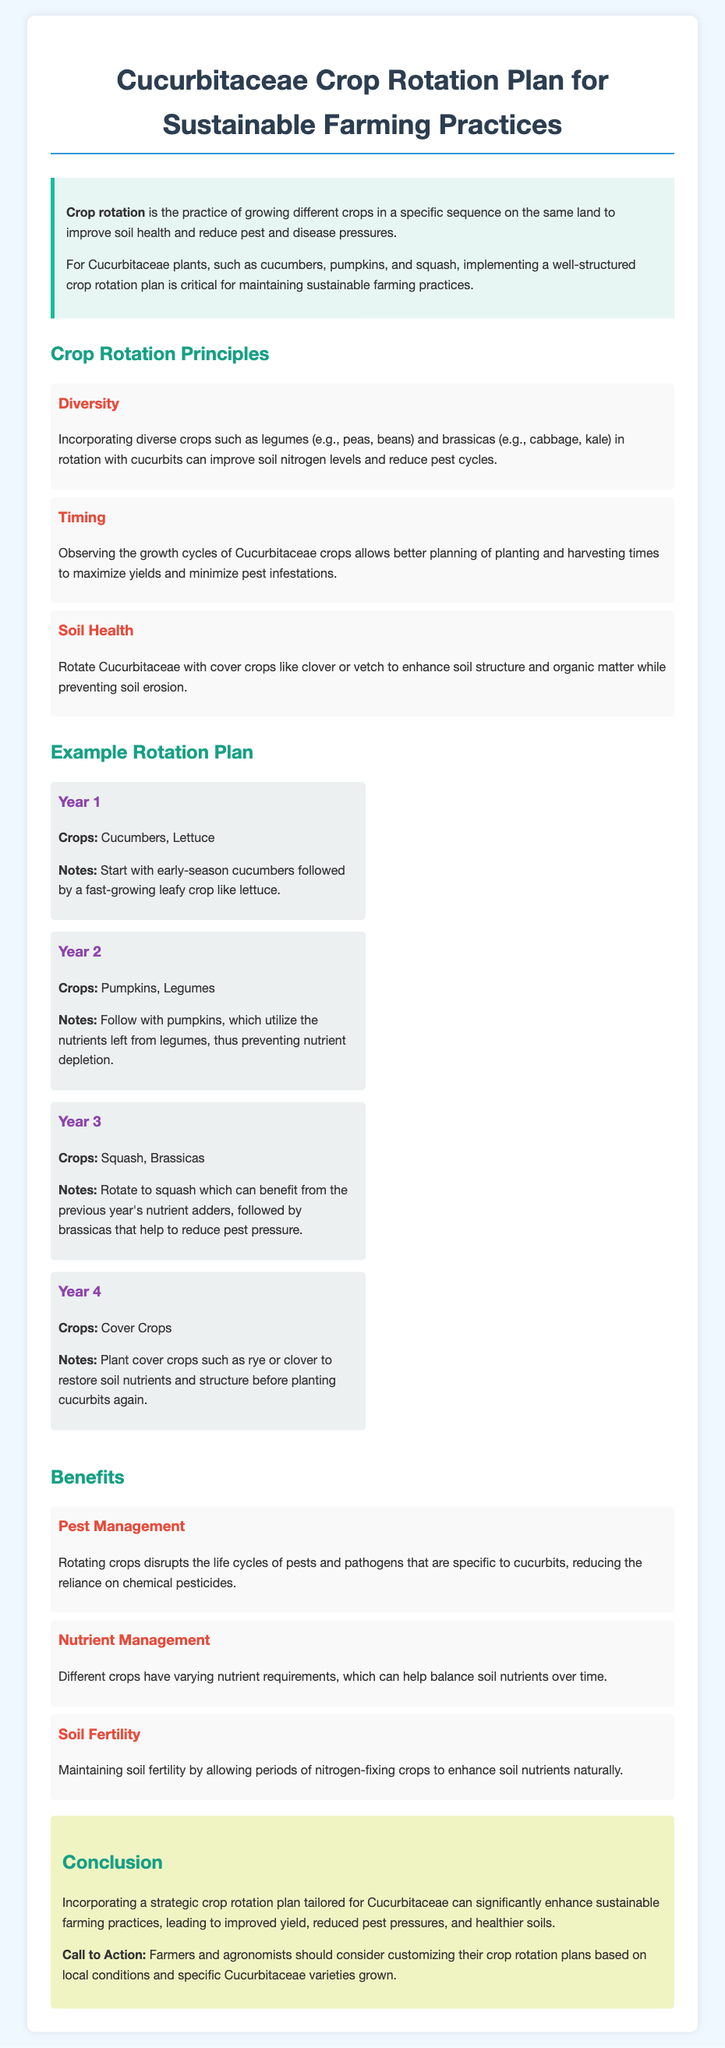What is the main topic of the document? The document focuses on the planning of sustainable farming practices specific to Cucurbitaceae crops through crop rotation.
Answer: Cucurbitaceae Crop Rotation Plan What crops are grown in Year 1? The first year's crops listed in the rotation plan are cucumbers and lettuce.
Answer: Cucumbers, Lettuce What is a key principle mentioned in the document? A principle for crop rotation highlighted in the document is diversity, which includes incorporating a variety of crops.
Answer: Diversity Which crop is included in Year 3? The crops in the third year of the rotation plan include squash and brassicas.
Answer: Squash, Brassicas How many years does the example rotation plan cover? The rotation plan provides an example for four consecutive years.
Answer: Four What benefit does crop rotation provide in pest management? Crop rotation disrupts the life cycles of specific pests and pathogens related to cucurbits.
Answer: Reducing reliance on chemical pesticides What is the purpose of planting cover crops in Year 4? The goal of planting cover crops is to restore soil nutrients and structure before replanting cucurbits.
Answer: Restore soil nutrients and structure What should farmers consider when customizing their rotation plans? Farmers should tailor their plans based on local conditions and specific varieties of Cucurbitaceae grown.
Answer: Local conditions and specific varieties 